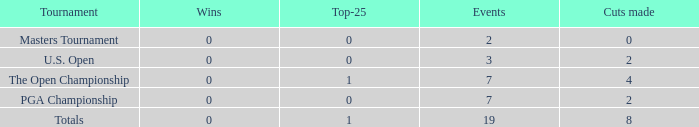Could you parse the entire table? {'header': ['Tournament', 'Wins', 'Top-25', 'Events', 'Cuts made'], 'rows': [['Masters Tournament', '0', '0', '2', '0'], ['U.S. Open', '0', '0', '3', '2'], ['The Open Championship', '0', '1', '7', '4'], ['PGA Championship', '0', '0', '7', '2'], ['Totals', '0', '1', '19', '8']]} What is the overall count of cuts made in tournaments featuring 2 events? 1.0. 